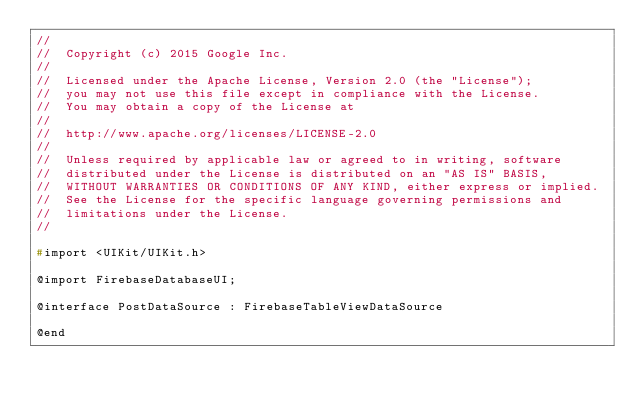<code> <loc_0><loc_0><loc_500><loc_500><_C_>//
//  Copyright (c) 2015 Google Inc.
//
//  Licensed under the Apache License, Version 2.0 (the "License");
//  you may not use this file except in compliance with the License.
//  You may obtain a copy of the License at
//
//  http://www.apache.org/licenses/LICENSE-2.0
//
//  Unless required by applicable law or agreed to in writing, software
//  distributed under the License is distributed on an "AS IS" BASIS,
//  WITHOUT WARRANTIES OR CONDITIONS OF ANY KIND, either express or implied.
//  See the License for the specific language governing permissions and
//  limitations under the License.
//

#import <UIKit/UIKit.h>

@import FirebaseDatabaseUI;

@interface PostDataSource : FirebaseTableViewDataSource

@end
</code> 